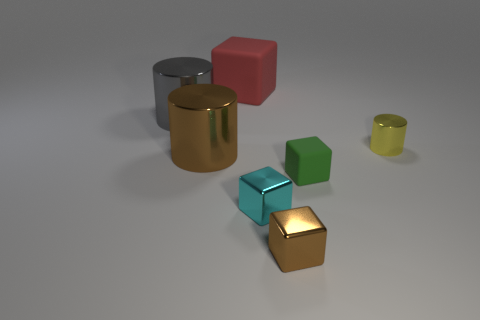There is a metallic cylinder that is in front of the small yellow metal object; does it have the same color as the shiny cube that is on the right side of the cyan object?
Your response must be concise. Yes. There is a thing that is behind the big brown metallic cylinder and right of the tiny brown object; what shape is it?
Ensure brevity in your answer.  Cylinder. Are there any red shiny things that have the same shape as the large matte object?
Give a very brief answer. No. The brown shiny object that is the same size as the red rubber object is what shape?
Offer a terse response. Cylinder. What material is the large red cube?
Ensure brevity in your answer.  Rubber. There is a thing behind the large metallic cylinder left of the brown metallic object to the left of the big cube; what is its size?
Ensure brevity in your answer.  Large. How many metal things are either big red objects or green objects?
Provide a succinct answer. 0. The gray metallic cylinder is what size?
Your response must be concise. Large. What number of things are tiny cyan objects or brown metal cubes that are to the left of the tiny yellow shiny object?
Ensure brevity in your answer.  2. How many other things are the same color as the tiny matte block?
Make the answer very short. 0. 